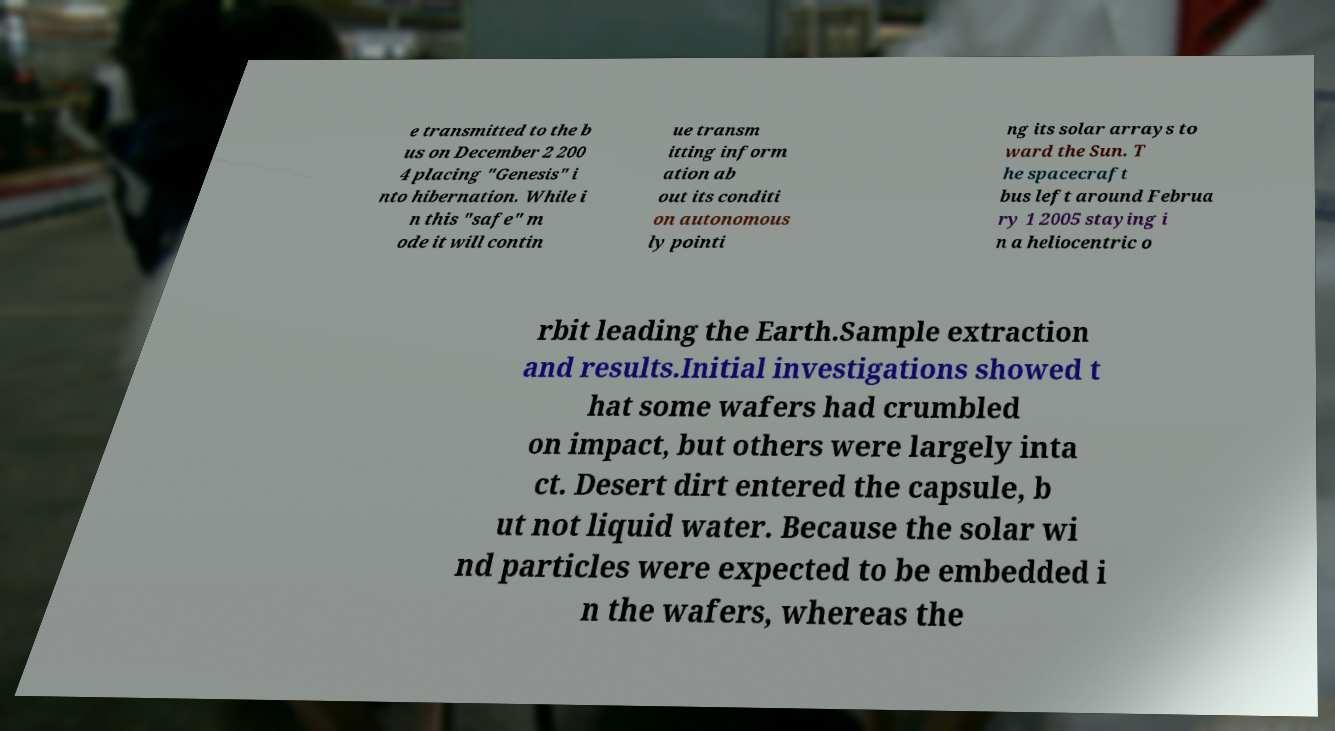Could you extract and type out the text from this image? e transmitted to the b us on December 2 200 4 placing "Genesis" i nto hibernation. While i n this "safe" m ode it will contin ue transm itting inform ation ab out its conditi on autonomous ly pointi ng its solar arrays to ward the Sun. T he spacecraft bus left around Februa ry 1 2005 staying i n a heliocentric o rbit leading the Earth.Sample extraction and results.Initial investigations showed t hat some wafers had crumbled on impact, but others were largely inta ct. Desert dirt entered the capsule, b ut not liquid water. Because the solar wi nd particles were expected to be embedded i n the wafers, whereas the 